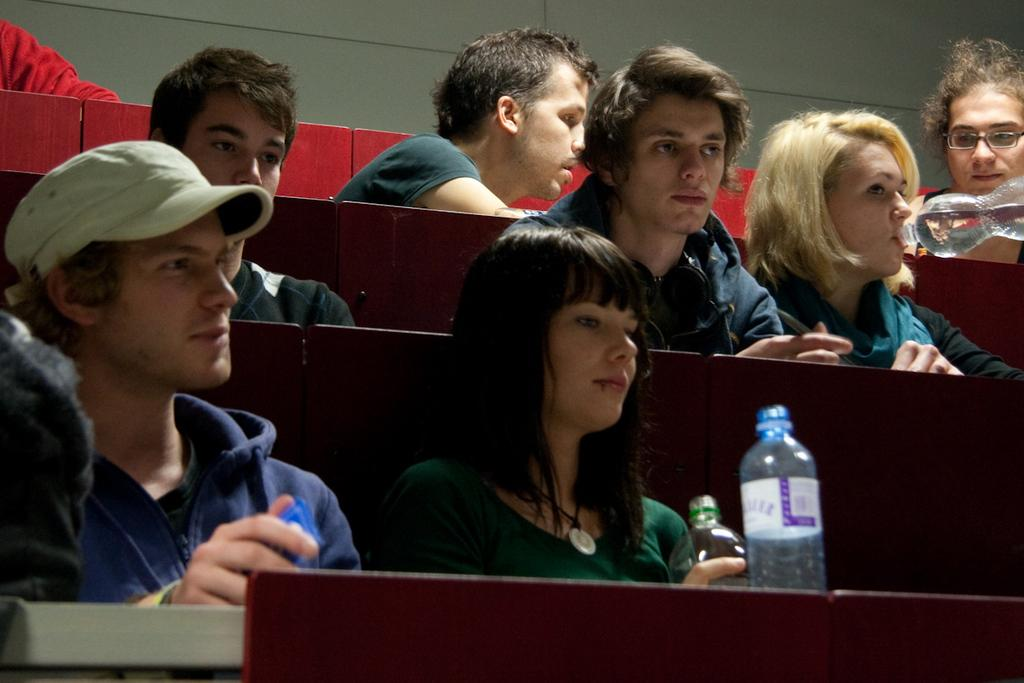What are the people in the image doing? There are people sitting in the image. Can you describe the activity of one of the individuals? A woman is drinking water in the image. What objects can be seen on the table in the image? There are two bottles on a table in the image. What is the limit of respect shown by the mother in the image? There is no mother present in the image, and therefore no limit of respect can be determined. 